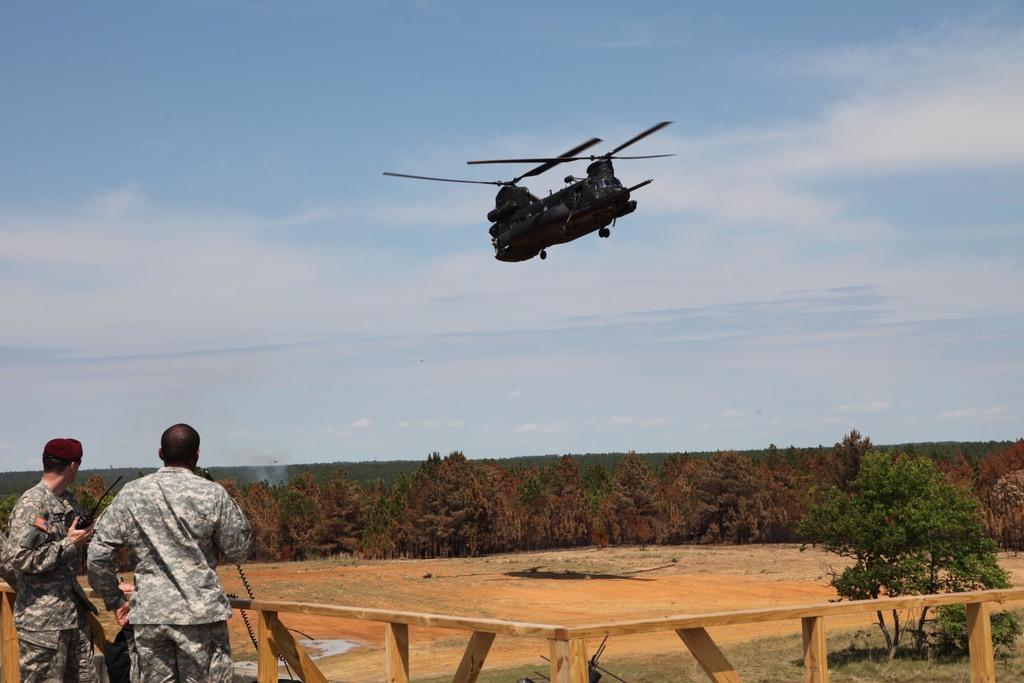Please provide a concise description of this image. In this picture there is a plane which is in black color is flying in air and there are two persons standing in the left corner and there is a fence in front of them and there are trees in the background. 